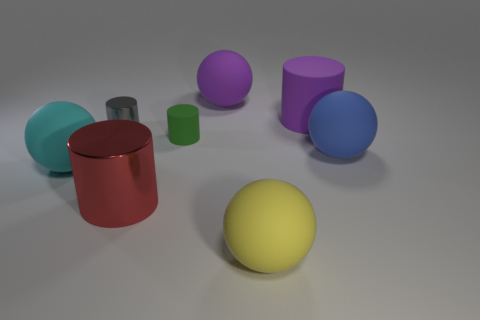Subtract all small metal cylinders. How many cylinders are left? 3 Add 1 purple rubber spheres. How many objects exist? 9 Subtract 1 cylinders. How many cylinders are left? 3 Subtract all purple spheres. How many spheres are left? 3 Subtract all large yellow balls. Subtract all big matte objects. How many objects are left? 2 Add 4 yellow rubber spheres. How many yellow rubber spheres are left? 5 Add 4 tiny matte objects. How many tiny matte objects exist? 5 Subtract 0 cyan cubes. How many objects are left? 8 Subtract all cyan balls. Subtract all green cylinders. How many balls are left? 3 Subtract all gray spheres. How many gray cylinders are left? 1 